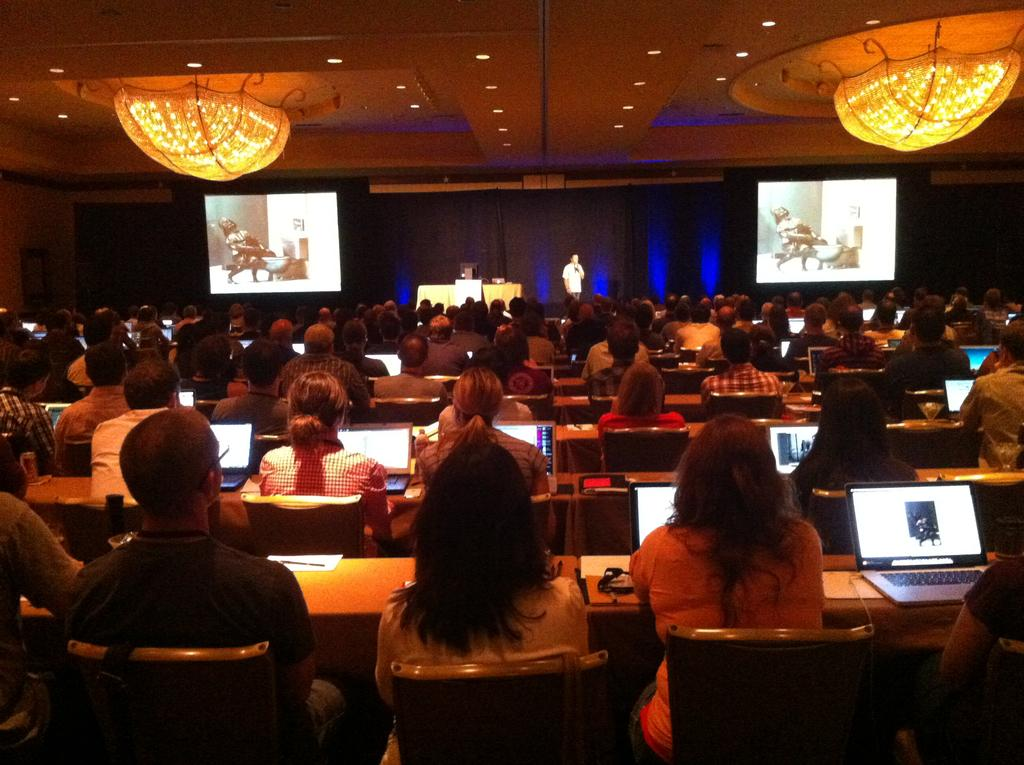What type of building is shown in the image? There is an auditorium in the image. How many people are present in the auditorium? There are many people in the auditorium. What are the people doing in the image? The people are sitting on chairs and using laptops. What objects are provided for each person in the auditorium? Each person has a desk. What type of health issues are the people in the image discussing? There is no indication in the image that the people are discussing health issues. What type of pancake is being served to the people in the image? There is no pancake present in the image; the people are using laptops. 